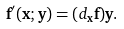<formula> <loc_0><loc_0><loc_500><loc_500>\mathbf f ^ { \prime } ( \mathbf x ; \mathbf y ) = ( d _ { \mathbf x } \mathbf f ) \mathbf y .</formula> 